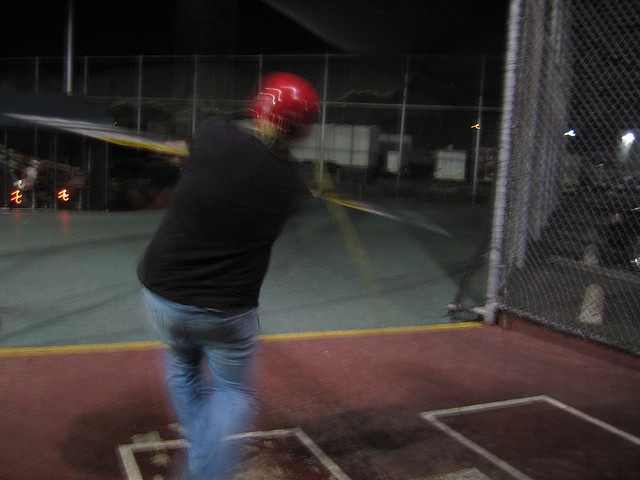Describe the objects in this image and their specific colors. I can see people in black, gray, and darkblue tones, car in black and gray tones, and car in black and gray tones in this image. 